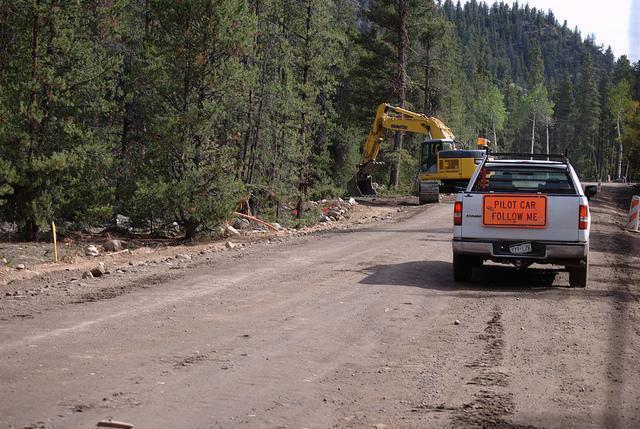What are you instructed to do?
Make your selection and explain in format: 'Answer: answer
Rationale: rationale.'
Options: Watch out, follow car, turn left, stop. Answer: follow car.
Rationale: The pilot car wants the other vehicles to follow him. 